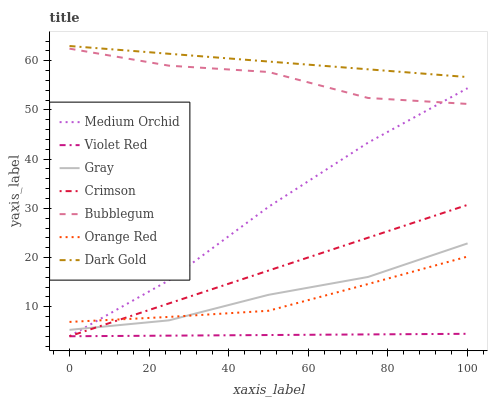Does Violet Red have the minimum area under the curve?
Answer yes or no. Yes. Does Dark Gold have the maximum area under the curve?
Answer yes or no. Yes. Does Dark Gold have the minimum area under the curve?
Answer yes or no. No. Does Violet Red have the maximum area under the curve?
Answer yes or no. No. Is Violet Red the smoothest?
Answer yes or no. Yes. Is Bubblegum the roughest?
Answer yes or no. Yes. Is Dark Gold the smoothest?
Answer yes or no. No. Is Dark Gold the roughest?
Answer yes or no. No. Does Dark Gold have the lowest value?
Answer yes or no. No. Does Dark Gold have the highest value?
Answer yes or no. Yes. Does Violet Red have the highest value?
Answer yes or no. No. Is Violet Red less than Orange Red?
Answer yes or no. Yes. Is Bubblegum greater than Orange Red?
Answer yes or no. Yes. Does Crimson intersect Orange Red?
Answer yes or no. Yes. Is Crimson less than Orange Red?
Answer yes or no. No. Is Crimson greater than Orange Red?
Answer yes or no. No. Does Violet Red intersect Orange Red?
Answer yes or no. No. 